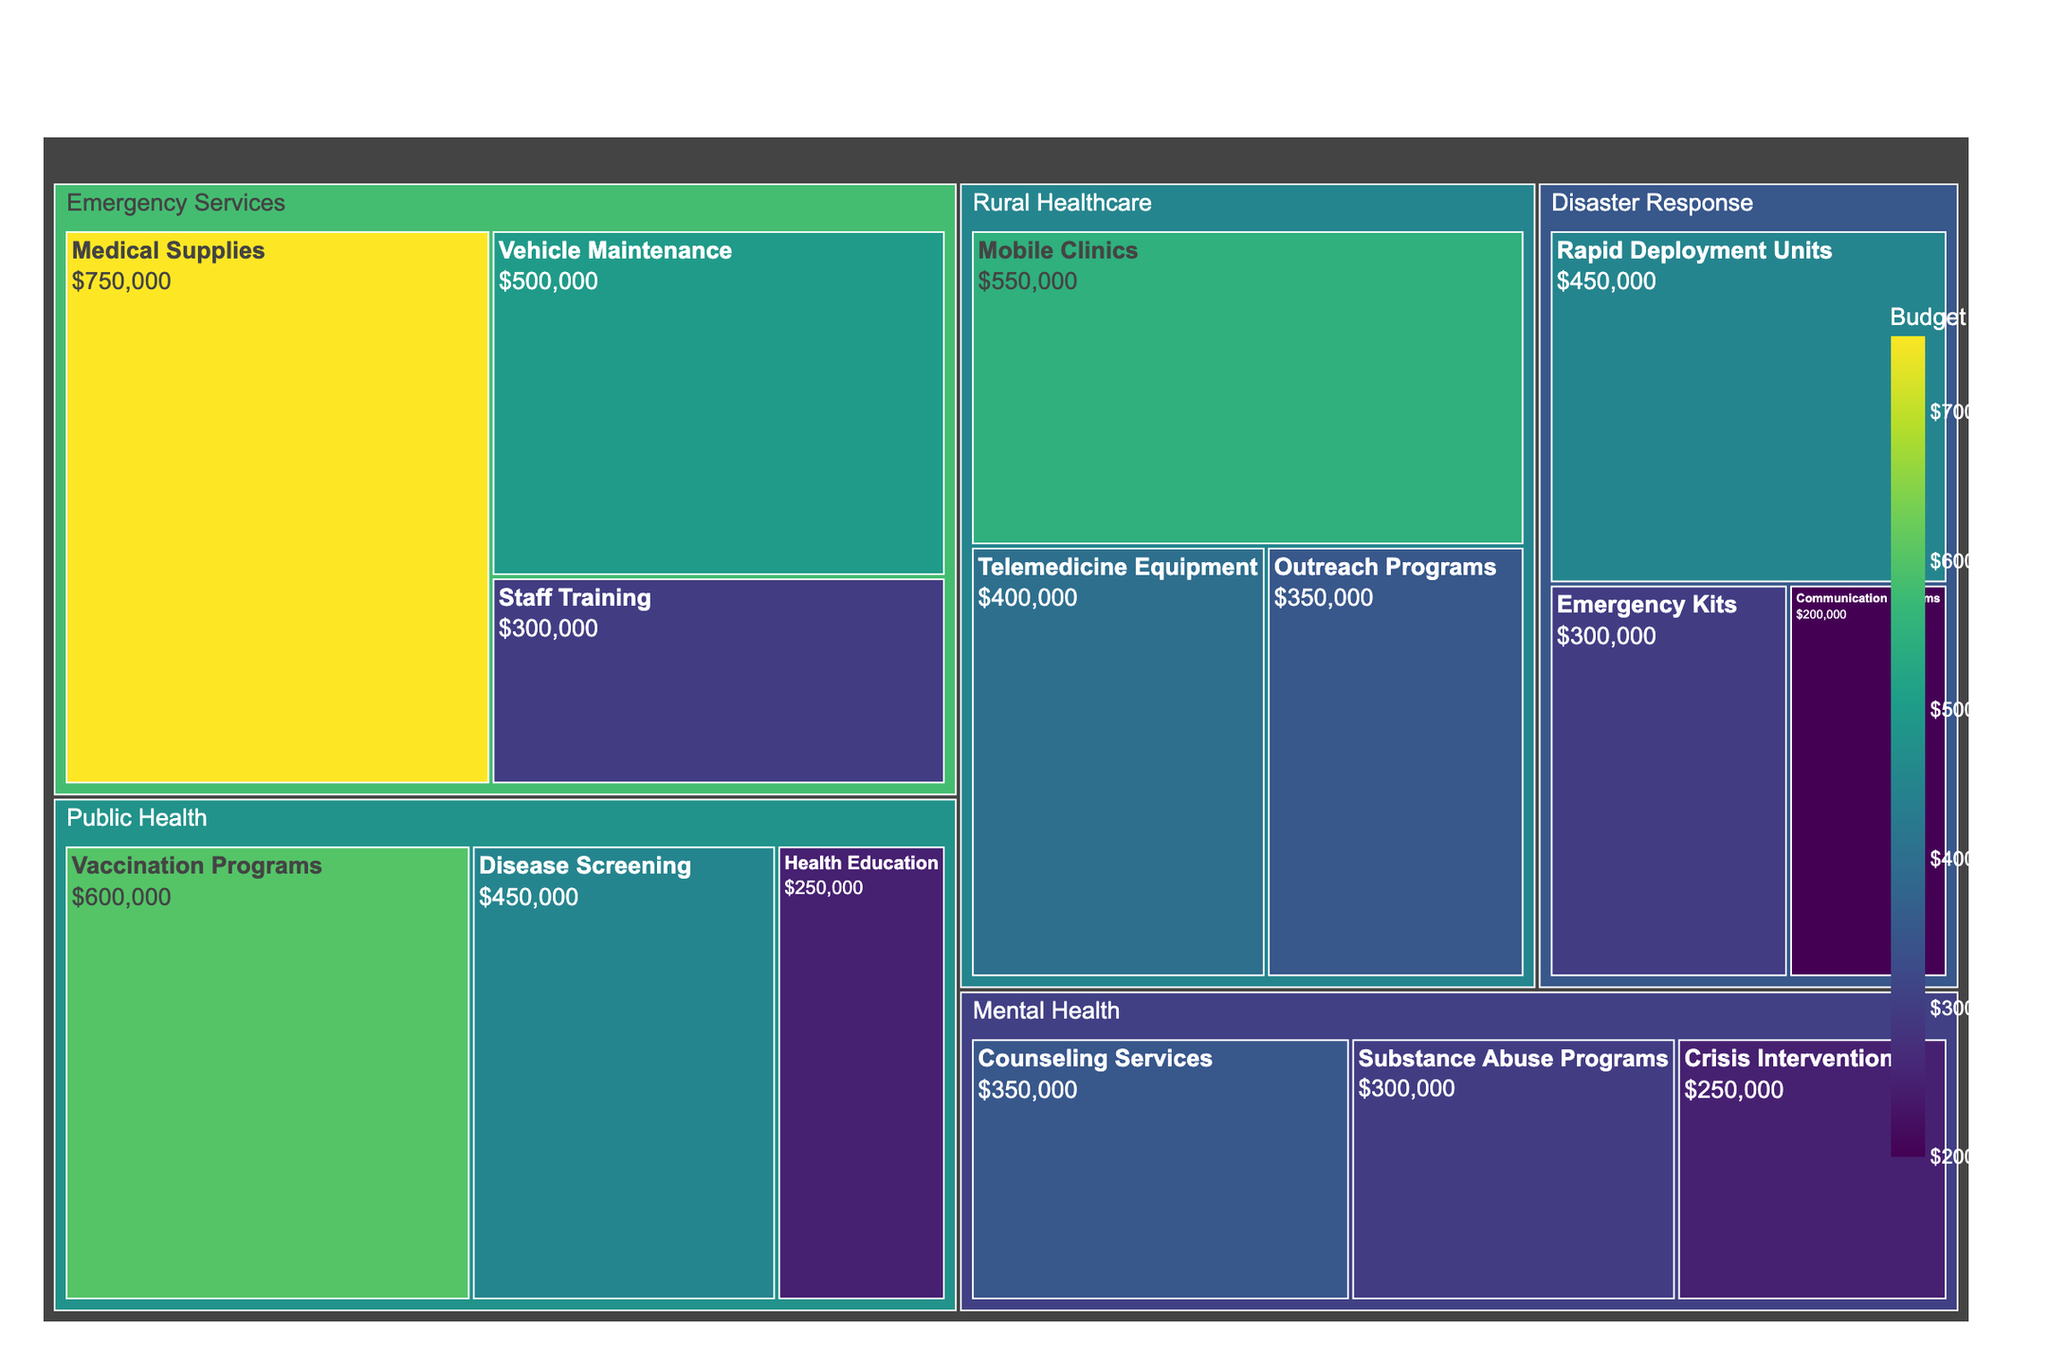What's the total budget allocated to the Emergency Services department? To find the total budget allocated to the Emergency Services department, sum the budgets for Vehicle Maintenance, Medical Supplies, and Staff Training. That's $500,000 + $750,000 + $300,000, which equals $1,550,000.
Answer: $1,550,000 Which category in the Public Health department has the highest budget allocation? Look for the category within the Public Health department that has the largest budget. Vaccination Programs has a budget of $600,000, which is higher than Disease Screening ($450,000) and Health Education ($250,000).
Answer: Vaccination Programs How does the budget for Disaster Response's Rapid Deployment Units compare to Mental Health's Counseling Services? Compare the budget for Rapid Deployment Units ($450,000) with that for Counseling Services ($350,000). Rapid Deployment Units have a higher budget.
Answer: Rapid Deployment Units has a higher budget What is the total budget for Disease Screening and Telemedicine Equipment? Add the budgets for Disease Screening ($450,000) and Telemedicine Equipment ($400,000). The total is $450,000 + $400,000, which equals $850,000.
Answer: $850,000 Which department has the lowest single category budget and what is that category? Identify the smallest budget figure on the treemap. The smallest budget is for Disaster Response's Communication Systems at $200,000.
Answer: Disaster Response's Communication Systems Compare the total budget for Rural Healthcare with that of Mental Health. Calculate the total budget for each department. Rural Healthcare's total is $400,000 (Telemedicine Equipment) + $350,000 (Outreach Programs) + $550,000 (Mobile Clinics) = $1,300,000. Mental Health's total is $350,000 (Counseling Services) + $300,000 (Substance Abuse Programs) + $250,000 (Crisis Intervention) = $900,000. Rural Healthcare's total is greater.
Answer: Rural Healthcare's total is greater How much more budget is allocated to Public Health than to Disaster Response? Calculate the total budget for each department. Public Health: $600,000 (Vaccination Programs) + $450,000 (Disease Screening) + $250,000 (Health Education) = $1,300,000. Disaster Response: $300,000 (Emergency Kits) + $200,000 (Communication Systems) + $450,000 (Rapid Deployment Units) = $950,000. The difference is $1,300,000 - $950,000 = $350,000.
Answer: $350,000 What's the average budget for categories in Mental Health? Sum the budgets in Mental Health, then divide by the number of categories. $350,000 + $300,000 + $250,000 = $900,000. There are 3 categories, so $900,000 / 3 = $300,000.
Answer: $300,000 Which department receives the highest total budget allocation? Compare the total budgets of all departments. Emergency Services: $1,550,000, Public Health: $1,300,000, Rural Healthcare: $1,300,000, Disaster Response: $950,000, Mental Health: $900,000. Emergency Services has the highest total.
Answer: Emergency Services 